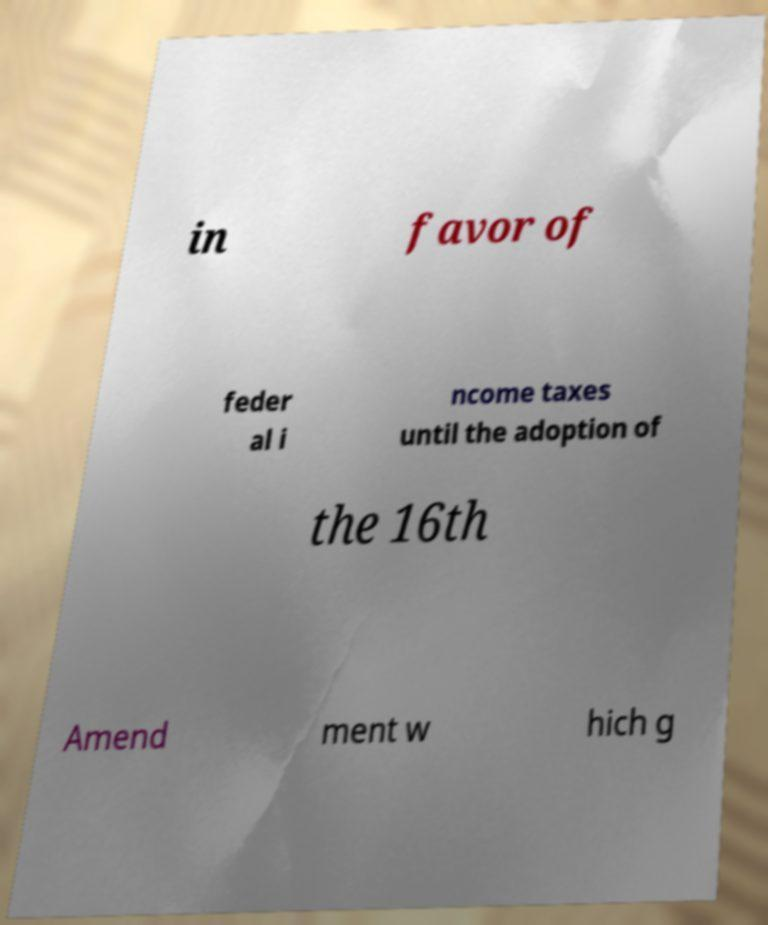What messages or text are displayed in this image? I need them in a readable, typed format. in favor of feder al i ncome taxes until the adoption of the 16th Amend ment w hich g 